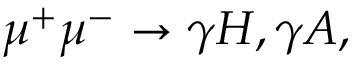<formula> <loc_0><loc_0><loc_500><loc_500>\mu ^ { + } \mu ^ { - } \rightarrow \gamma H , \gamma A ,</formula> 